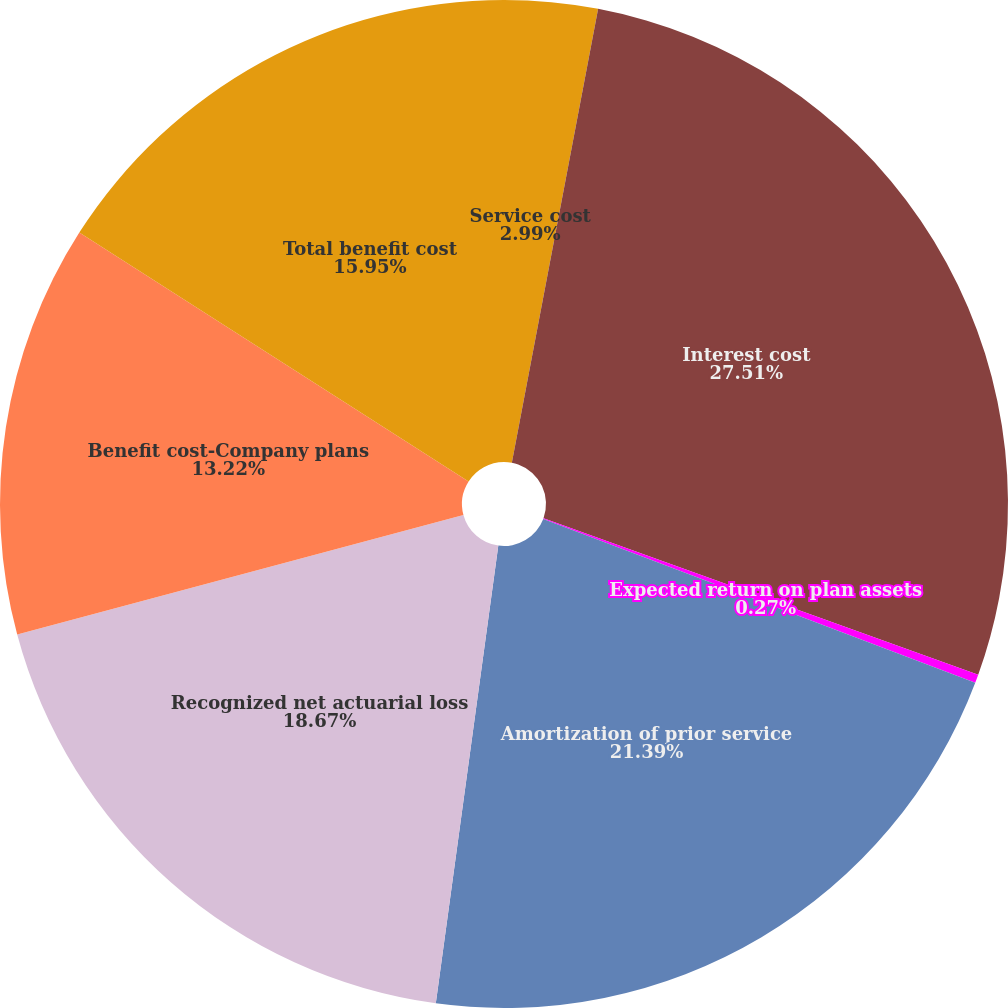Convert chart to OTSL. <chart><loc_0><loc_0><loc_500><loc_500><pie_chart><fcel>Service cost<fcel>Interest cost<fcel>Expected return on plan assets<fcel>Amortization of prior service<fcel>Recognized net actuarial loss<fcel>Benefit cost-Company plans<fcel>Total benefit cost<nl><fcel>2.99%<fcel>27.51%<fcel>0.27%<fcel>21.39%<fcel>18.67%<fcel>13.22%<fcel>15.95%<nl></chart> 